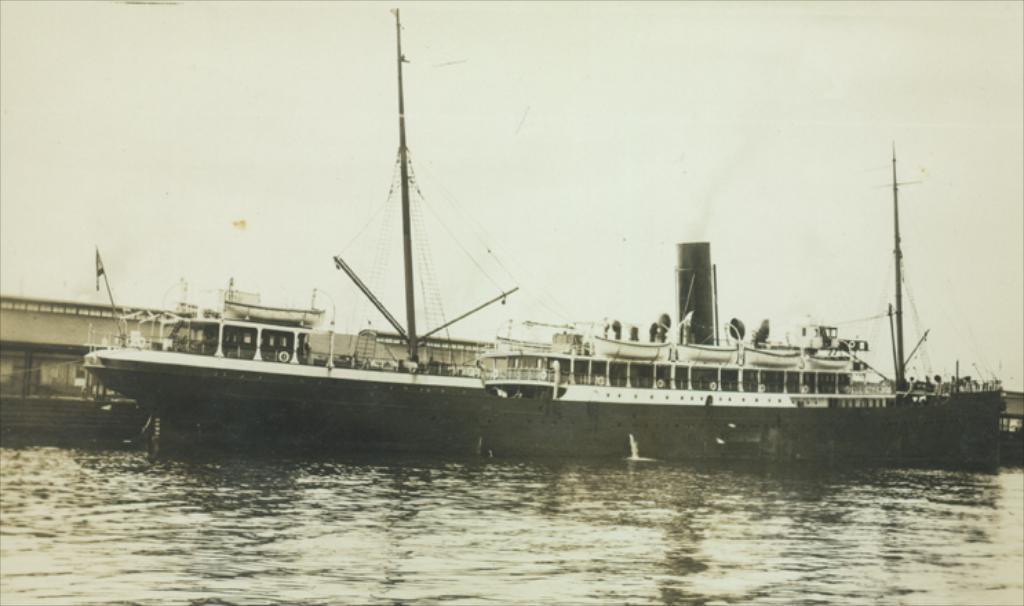What is the main subject of the image? The main subject of the image is a boat. Where is the boat located? The boat is on the water. What can be seen in the image besides the boat? There is a flag, poles, a container, a house in the background, and the sky visible in the background. How many bikes are parked near the boat in the image? There are no bikes present in the image. What type of connection is established between the boat and the container in the image? There is no connection between the boat and the container in the image; they are separate objects. 